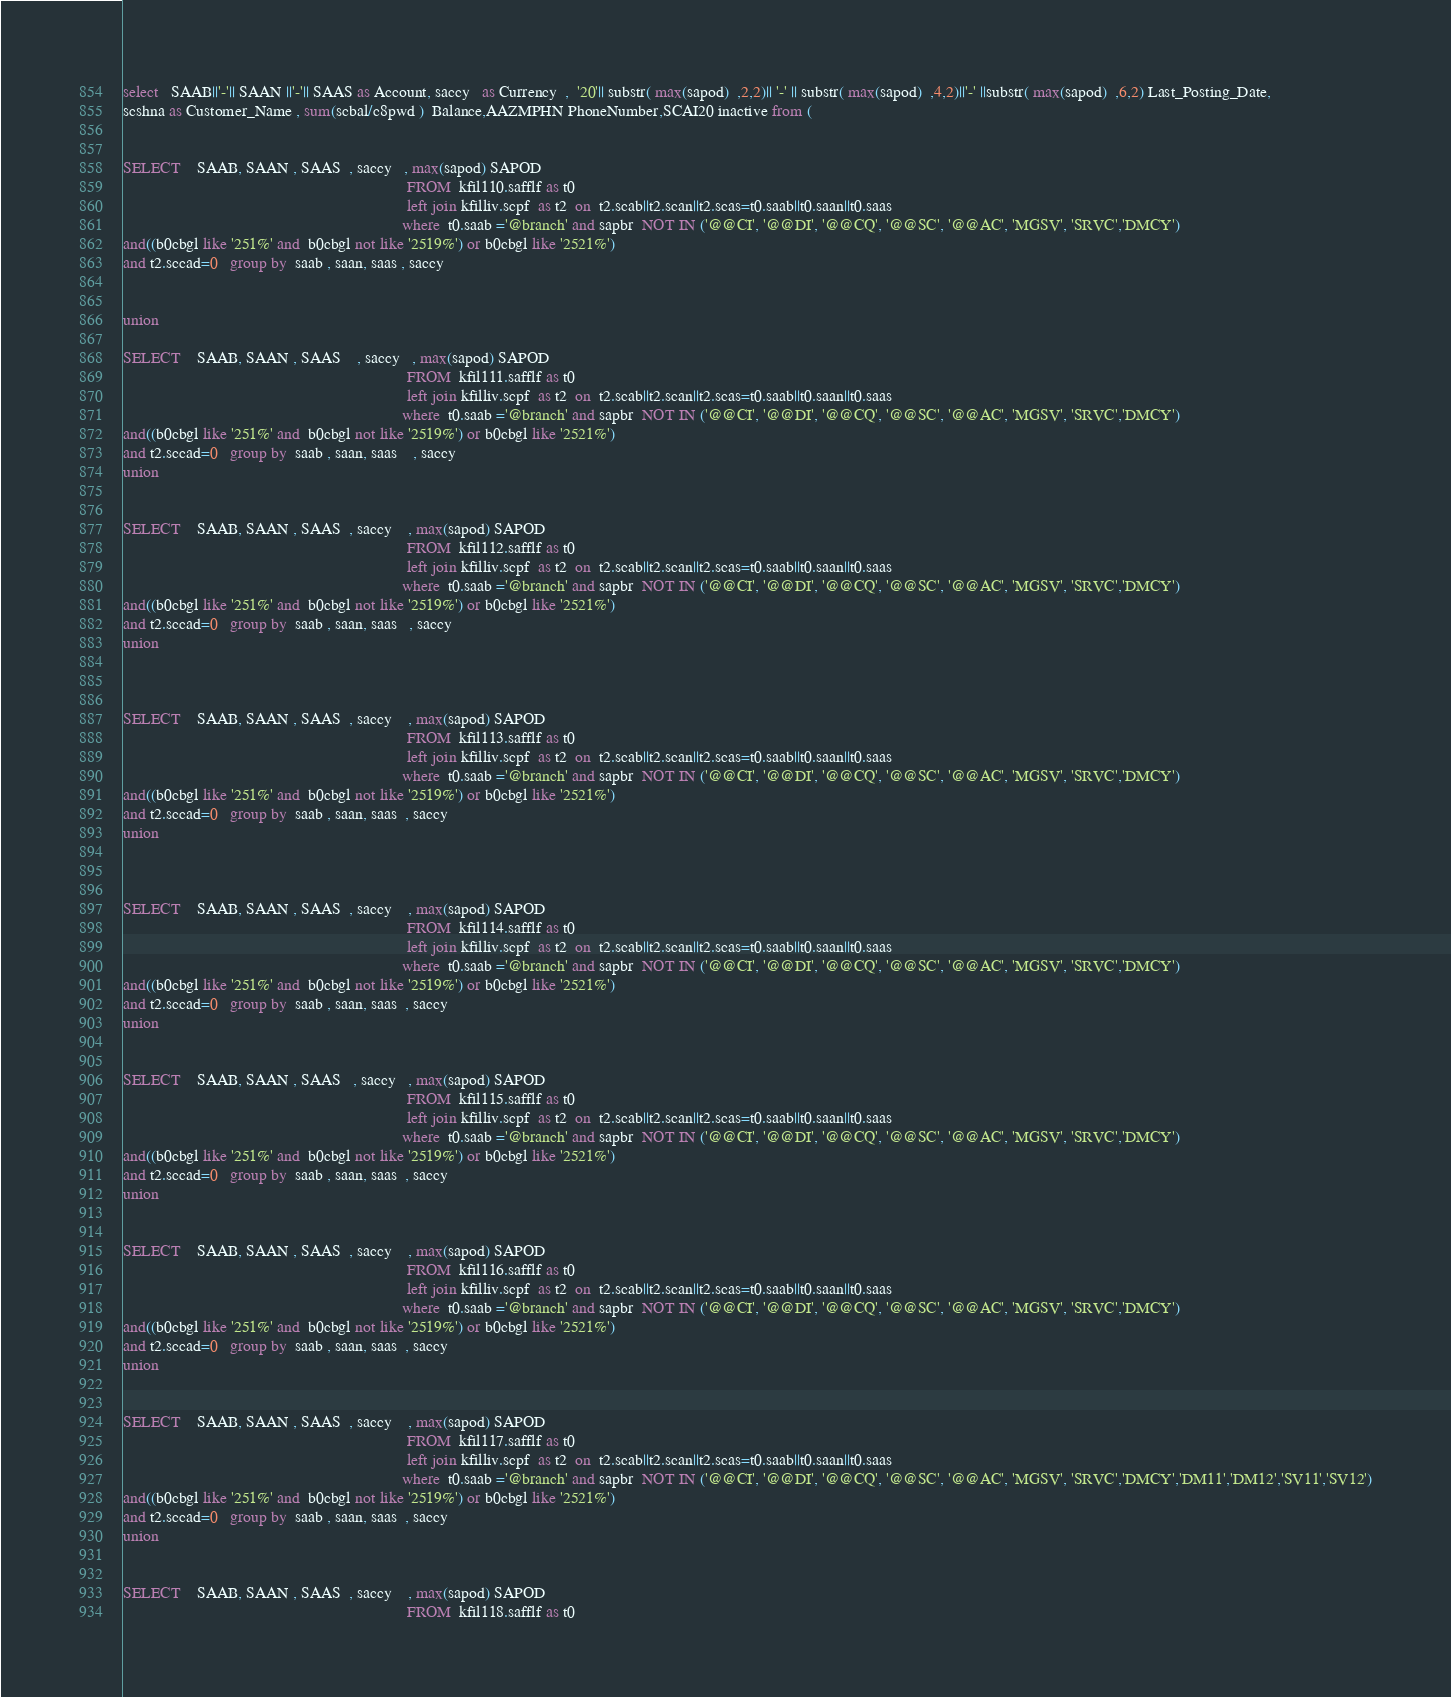<code> <loc_0><loc_0><loc_500><loc_500><_SQL_>select   SAAB||'-'|| SAAN ||'-'|| SAAS as Account, saccy   as Currency  ,  '20'|| substr( max(sapod)  ,2,2)|| '-' || substr( max(sapod)  ,4,2)||'-' ||substr( max(sapod)  ,6,2) Last_Posting_Date,
scshna as Customer_Name , sum(scbal/c8pwd )  Balance,AAZMPHN PhoneNumber,SCAI20 inactive from (


SELECT    SAAB, SAAN , SAAS  , saccy   , max(sapod) SAPOD
                                                                     FROM  kfil110.safflf as t0
                                                                     left join kfilliv.scpf  as t2  on  t2.scab||t2.scan||t2.scas=t0.saab||t0.saan||t0.saas
                                                                    where  t0.saab ='@branch' and sapbr  NOT IN ('@@CI', '@@DI', '@@CQ', '@@SC', '@@AC', 'MGSV', 'SRVC','DMCY')
and((b0cbgl like '251%' and  b0cbgl not like '2519%') or b0cbgl like '2521%')
and t2.sccad=0   group by  saab , saan, saas , saccy


union

SELECT    SAAB, SAAN , SAAS    , saccy   , max(sapod) SAPOD
                                                                     FROM  kfil111.safflf as t0
                                                                     left join kfilliv.scpf  as t2  on  t2.scab||t2.scan||t2.scas=t0.saab||t0.saan||t0.saas
                                                                    where  t0.saab ='@branch' and sapbr  NOT IN ('@@CI', '@@DI', '@@CQ', '@@SC', '@@AC', 'MGSV', 'SRVC','DMCY')
and((b0cbgl like '251%' and  b0cbgl not like '2519%') or b0cbgl like '2521%')
and t2.sccad=0   group by  saab , saan, saas    , saccy
union


SELECT    SAAB, SAAN , SAAS  , saccy    , max(sapod) SAPOD
                                                                     FROM  kfil112.safflf as t0
                                                                     left join kfilliv.scpf  as t2  on  t2.scab||t2.scan||t2.scas=t0.saab||t0.saan||t0.saas
                                                                    where  t0.saab ='@branch' and sapbr  NOT IN ('@@CI', '@@DI', '@@CQ', '@@SC', '@@AC', 'MGSV', 'SRVC','DMCY')
and((b0cbgl like '251%' and  b0cbgl not like '2519%') or b0cbgl like '2521%')
and t2.sccad=0   group by  saab , saan, saas   , saccy
union



SELECT    SAAB, SAAN , SAAS  , saccy    , max(sapod) SAPOD
                                                                     FROM  kfil113.safflf as t0
                                                                     left join kfilliv.scpf  as t2  on  t2.scab||t2.scan||t2.scas=t0.saab||t0.saan||t0.saas
                                                                    where  t0.saab ='@branch' and sapbr  NOT IN ('@@CI', '@@DI', '@@CQ', '@@SC', '@@AC', 'MGSV', 'SRVC','DMCY')
and((b0cbgl like '251%' and  b0cbgl not like '2519%') or b0cbgl like '2521%')
and t2.sccad=0   group by  saab , saan, saas  , saccy
union



SELECT    SAAB, SAAN , SAAS  , saccy    , max(sapod) SAPOD
                                                                     FROM  kfil114.safflf as t0
                                                                     left join kfilliv.scpf  as t2  on  t2.scab||t2.scan||t2.scas=t0.saab||t0.saan||t0.saas
                                                                    where  t0.saab ='@branch' and sapbr  NOT IN ('@@CI', '@@DI', '@@CQ', '@@SC', '@@AC', 'MGSV', 'SRVC','DMCY')
and((b0cbgl like '251%' and  b0cbgl not like '2519%') or b0cbgl like '2521%')
and t2.sccad=0   group by  saab , saan, saas  , saccy
union


SELECT    SAAB, SAAN , SAAS   , saccy   , max(sapod) SAPOD
                                                                     FROM  kfil115.safflf as t0
                                                                     left join kfilliv.scpf  as t2  on  t2.scab||t2.scan||t2.scas=t0.saab||t0.saan||t0.saas
                                                                    where  t0.saab ='@branch' and sapbr  NOT IN ('@@CI', '@@DI', '@@CQ', '@@SC', '@@AC', 'MGSV', 'SRVC','DMCY')
and((b0cbgl like '251%' and  b0cbgl not like '2519%') or b0cbgl like '2521%')
and t2.sccad=0   group by  saab , saan, saas  , saccy
union


SELECT    SAAB, SAAN , SAAS  , saccy    , max(sapod) SAPOD
                                                                     FROM  kfil116.safflf as t0
                                                                     left join kfilliv.scpf  as t2  on  t2.scab||t2.scan||t2.scas=t0.saab||t0.saan||t0.saas
                                                                    where  t0.saab ='@branch' and sapbr  NOT IN ('@@CI', '@@DI', '@@CQ', '@@SC', '@@AC', 'MGSV', 'SRVC','DMCY')
and((b0cbgl like '251%' and  b0cbgl not like '2519%') or b0cbgl like '2521%')
and t2.sccad=0   group by  saab , saan, saas  , saccy
union


SELECT    SAAB, SAAN , SAAS  , saccy    , max(sapod) SAPOD
                                                                     FROM  kfil117.safflf as t0
                                                                     left join kfilliv.scpf  as t2  on  t2.scab||t2.scan||t2.scas=t0.saab||t0.saan||t0.saas
                                                                    where  t0.saab ='@branch' and sapbr  NOT IN ('@@CI', '@@DI', '@@CQ', '@@SC', '@@AC', 'MGSV', 'SRVC','DMCY','DM11','DM12','SV11','SV12')
and((b0cbgl like '251%' and  b0cbgl not like '2519%') or b0cbgl like '2521%')
and t2.sccad=0   group by  saab , saan, saas  , saccy
union


SELECT    SAAB, SAAN , SAAS  , saccy    , max(sapod) SAPOD
                                                                     FROM  kfil118.safflf as t0</code> 